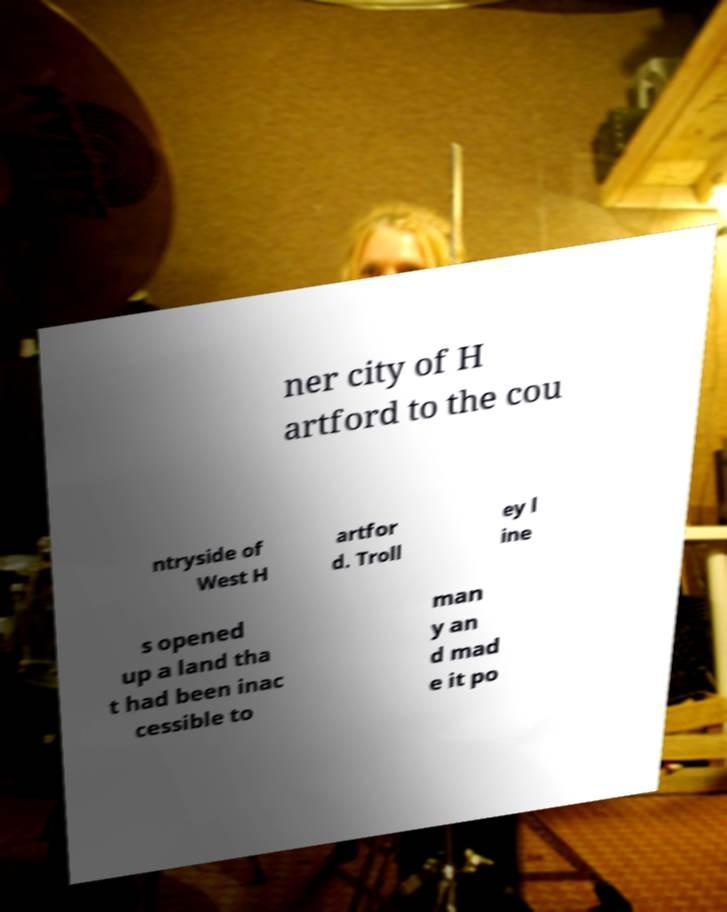There's text embedded in this image that I need extracted. Can you transcribe it verbatim? ner city of H artford to the cou ntryside of West H artfor d. Troll ey l ine s opened up a land tha t had been inac cessible to man y an d mad e it po 